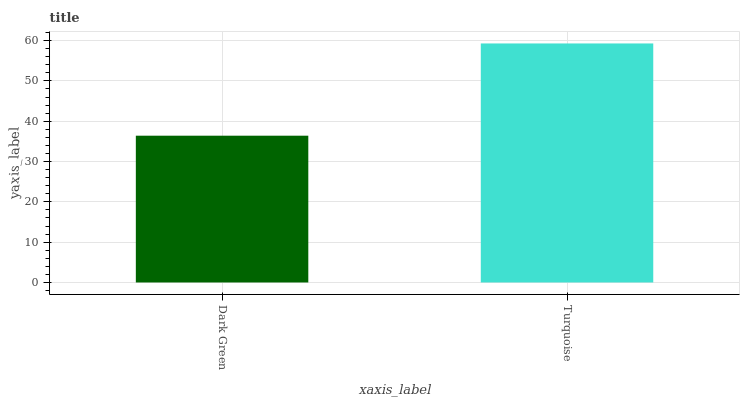Is Dark Green the minimum?
Answer yes or no. Yes. Is Turquoise the maximum?
Answer yes or no. Yes. Is Turquoise the minimum?
Answer yes or no. No. Is Turquoise greater than Dark Green?
Answer yes or no. Yes. Is Dark Green less than Turquoise?
Answer yes or no. Yes. Is Dark Green greater than Turquoise?
Answer yes or no. No. Is Turquoise less than Dark Green?
Answer yes or no. No. Is Turquoise the high median?
Answer yes or no. Yes. Is Dark Green the low median?
Answer yes or no. Yes. Is Dark Green the high median?
Answer yes or no. No. Is Turquoise the low median?
Answer yes or no. No. 